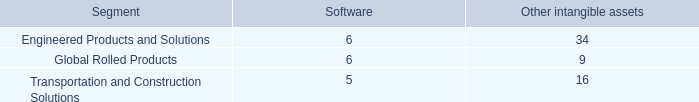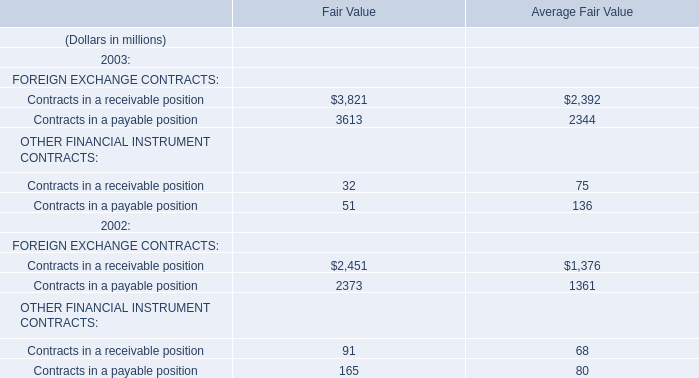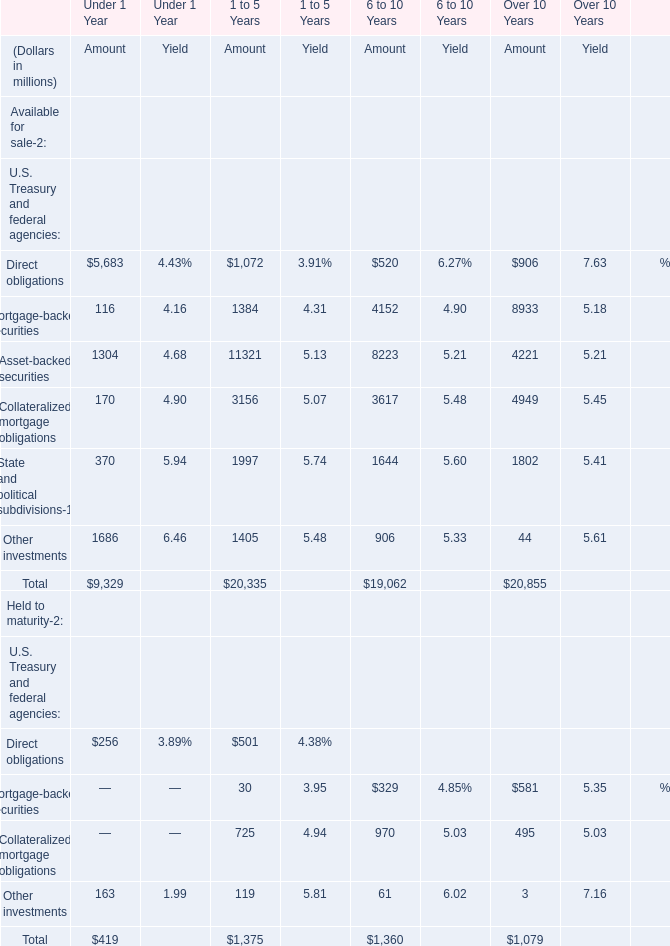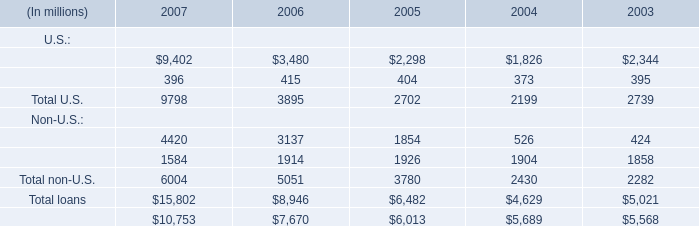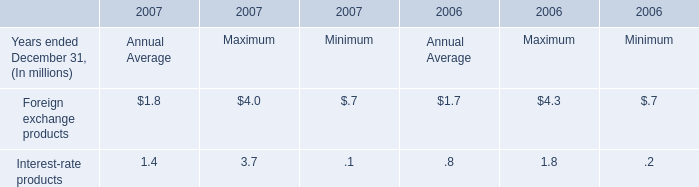What was the amount of Asset-backed securities in terms of Available for sale for 6 to 10 Years ? (in million) 
Answer: 8223. 